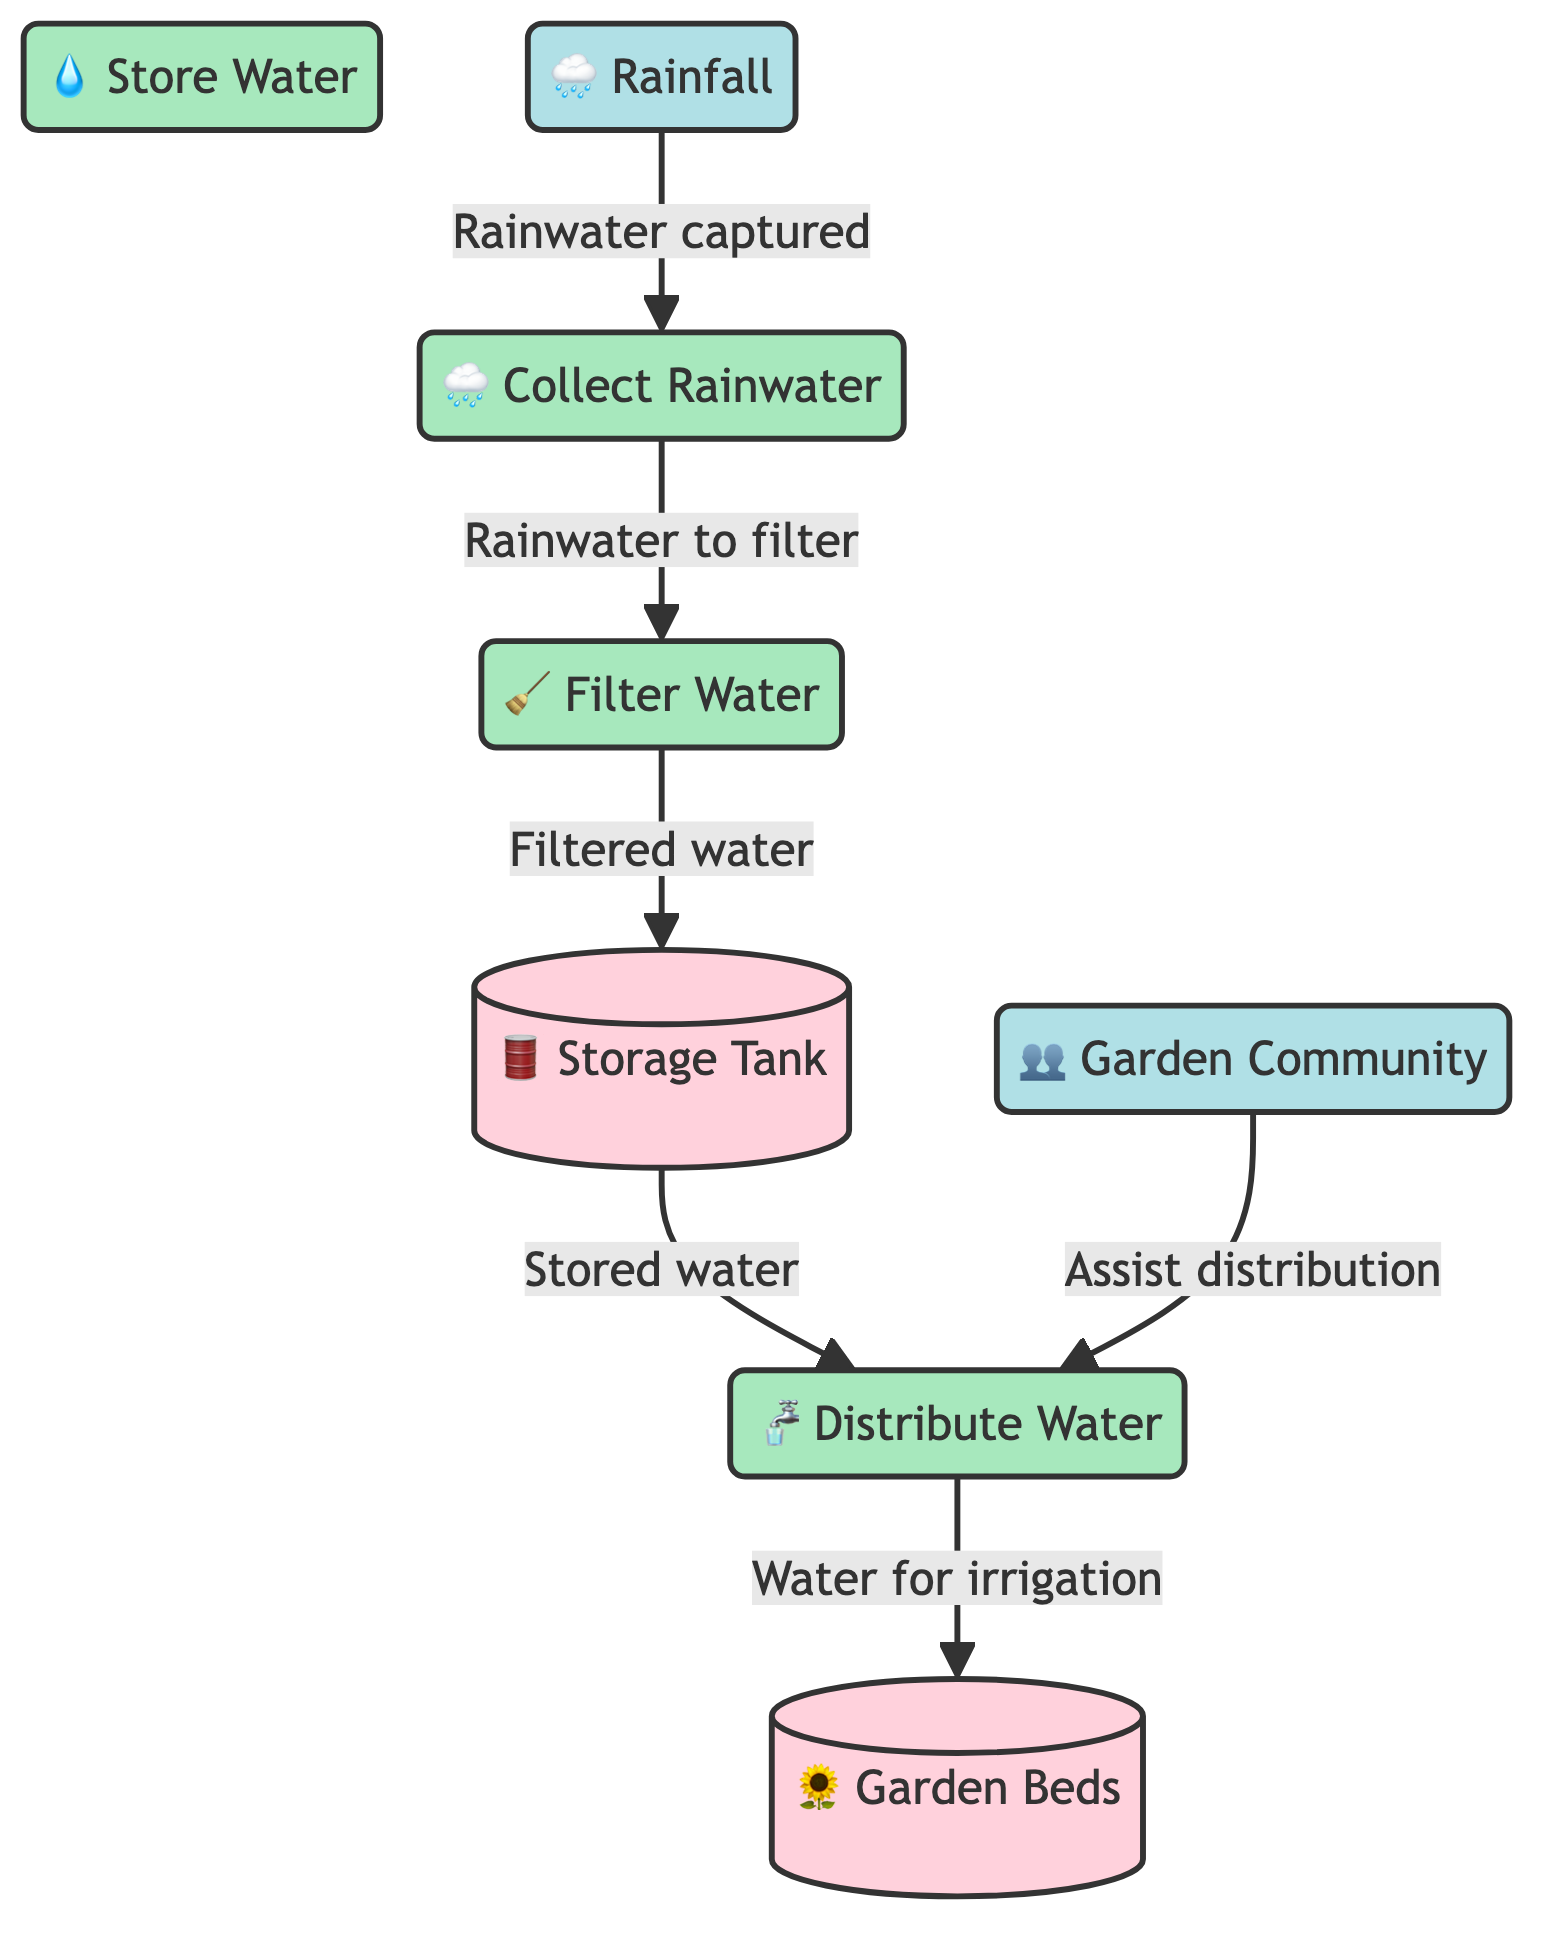What is the first process in the diagram? The first process is labeled as "Collect Rainwater" in the diagram. It is the initial step that begins the system's workflow for water conservation.
Answer: Collect Rainwater How many data stores are present in the diagram? The diagram features two data stores: "Storage Tank" and "Garden Beds." Counting these gives a total of two data stores.
Answer: 2 What is the source of the water captured in the system? The source of the water is indicated as "Rainfall" in the diagram, which is shown at the beginning of the process flow.
Answer: Rainfall What flows from the "Filter Water" process to the "Storage Tank"? The flow between these two nodes is labeled as "Filtered water," indicating that filtered water from the filtration process is stored in the storage tank next.
Answer: Filtered water Which entity assists in the water distribution process? The "Garden Community" is shown in the diagram to assist in the water distribution process, providing support to the "Distribute Water" step.
Answer: Garden Community What is the destination of the water distributed after leaving the "Distribute Water" process? The destination of the water distributed is "Garden Beds," which is indicated on the right side of the process flow.
Answer: Garden Beds What are the two main processes that involve the storage tank? The two main processes involving the "Storage Tank" are "Filter Water," which stores filtered water, and "Distribute Water," which distributes stored water for irrigation.
Answer: Filter Water, Distribute Water How does rainfall contribute to the system? Rainfall serves as the initial input that triggers the "Collect Rainwater" process, starting the sequence of capturing and utilizing rainwater.
Answer: Captured rainwater What type of diagram is depicted in this visual? The diagram is a "Data Flow Diagram," which illustrates how data (in this case, water) is collected, stored, and utilized within the system.
Answer: Data Flow Diagram 